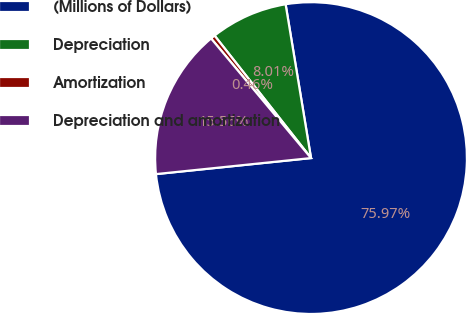<chart> <loc_0><loc_0><loc_500><loc_500><pie_chart><fcel>(Millions of Dollars)<fcel>Depreciation<fcel>Amortization<fcel>Depreciation and amortization<nl><fcel>75.96%<fcel>8.01%<fcel>0.46%<fcel>15.56%<nl></chart> 